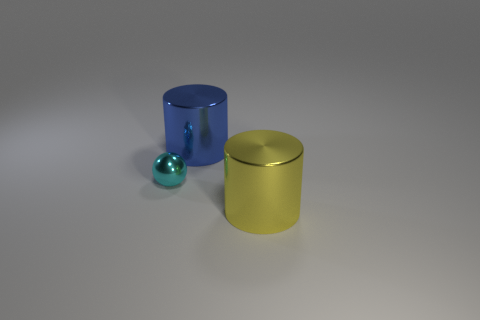Add 2 big rubber cubes. How many objects exist? 5 Subtract all cylinders. How many objects are left? 1 Add 1 purple matte cylinders. How many purple matte cylinders exist? 1 Subtract 0 brown cylinders. How many objects are left? 3 Subtract all brown cylinders. Subtract all green spheres. How many cylinders are left? 2 Subtract all brown spheres. How many blue cylinders are left? 1 Subtract all small blue objects. Subtract all tiny metallic spheres. How many objects are left? 2 Add 2 blue metallic cylinders. How many blue metallic cylinders are left? 3 